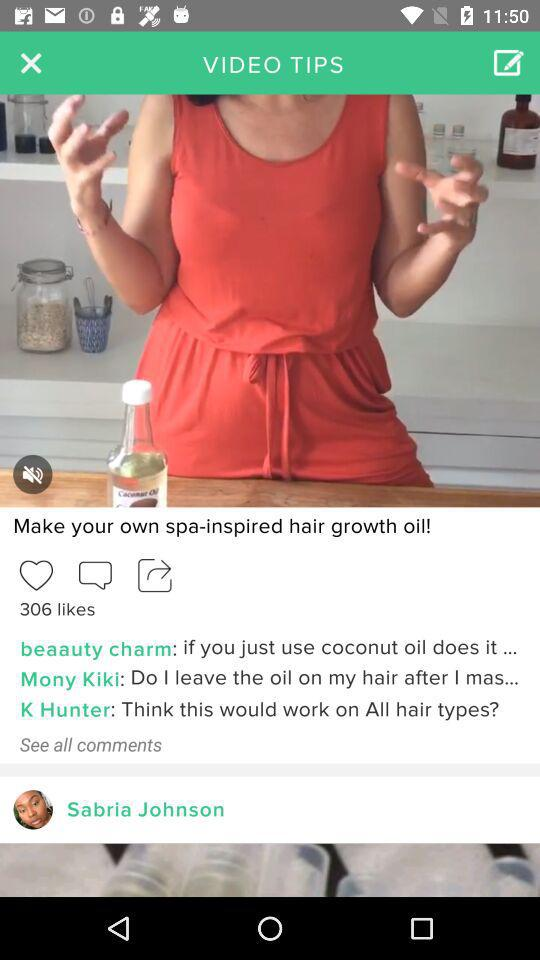How many people liked the video? The video was liked by 306 people. 